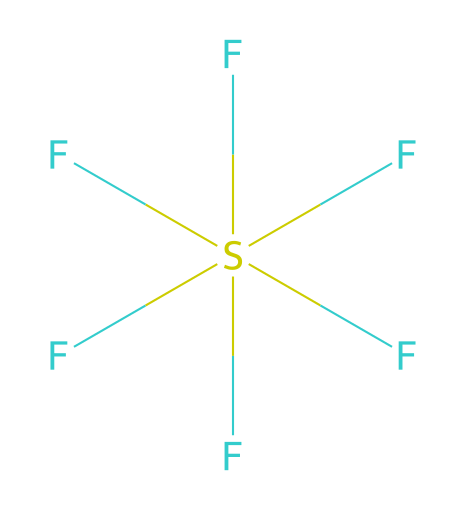What is the molecular formula of this compound? The SMILES representation indicates that the compound contains one sulfur atom and six fluorine atoms. In chemical notation, this is written as SF6.
Answer: SF6 How many fluorine atoms are present? By analyzing the SMILES, there are six instances of the fluorine atom (F) indicated adjacent to the sulfur atom (S).
Answer: 6 What type of bonding is present in sulfur hexafluoride? Sulfur hexafluoride has covalent bonds between the sulfur and fluorine atoms, as evident from the structure. Each fluorine atom is bonded to the sulfur atom through shared electrons.
Answer: covalent Is sulfur hexafluoride polar or nonpolar? Given the symmetrical arrangement of the six fluorine atoms around the central sulfur atom, the dipole moments cancel out, making the overall molecule nonpolar.
Answer: nonpolar What role does sulfur hexafluoride play in electrical insulation? Sulfur hexafluoride is used as an insulating gas in high-voltage electrical equipment due to its excellent dielectric properties and ability to prevent arcing between conductor parts.
Answer: insulating gas What is the oxidation state of sulfur in this compound? To determine the oxidation state, we note that fluorine typically has an oxidation state of -1. With six fluorines, the total contribution is -6. For the molecule to be neutral, sulfur must therefore be +6.
Answer: +6 